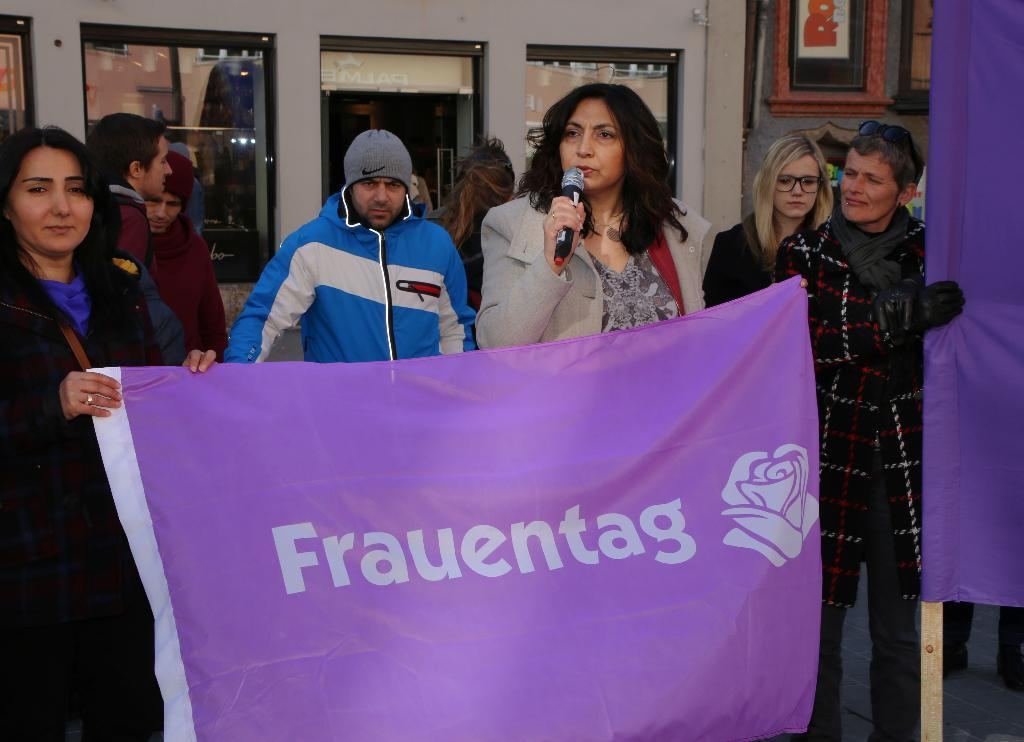Who is the main subject in the image? There is a woman in the image. What is the woman doing in the image? The woman is talking on a microphone. What else can be seen in the image besides the woman? There are people holding a banner in the image. What color is the banner? The banner is purple in color. What is visible in the background of the image? There appears to be a store in the background of the image. What direction is the thread pointing on the banner? There is no thread present on the banner in the image. 